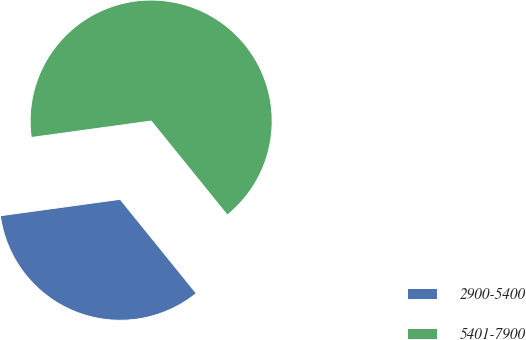Convert chart. <chart><loc_0><loc_0><loc_500><loc_500><pie_chart><fcel>2900-5400<fcel>5401-7900<nl><fcel>33.66%<fcel>66.34%<nl></chart> 